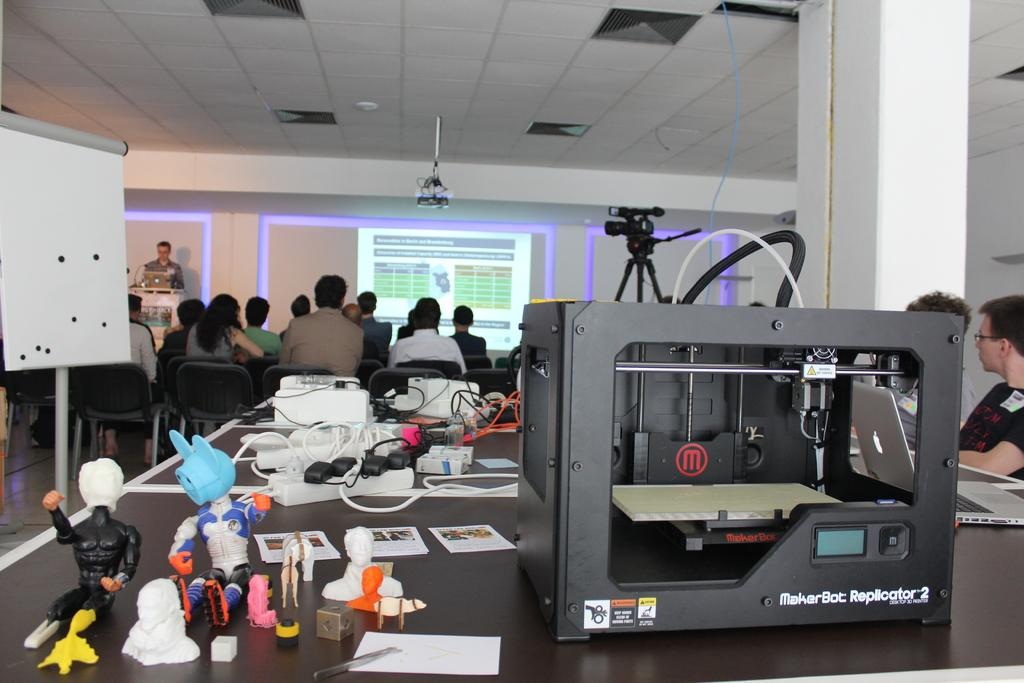Provide a one-sentence caption for the provided image. A Marker Bot Replicator 2 machine sitting on a table behind a group of people in a room sitting down. 